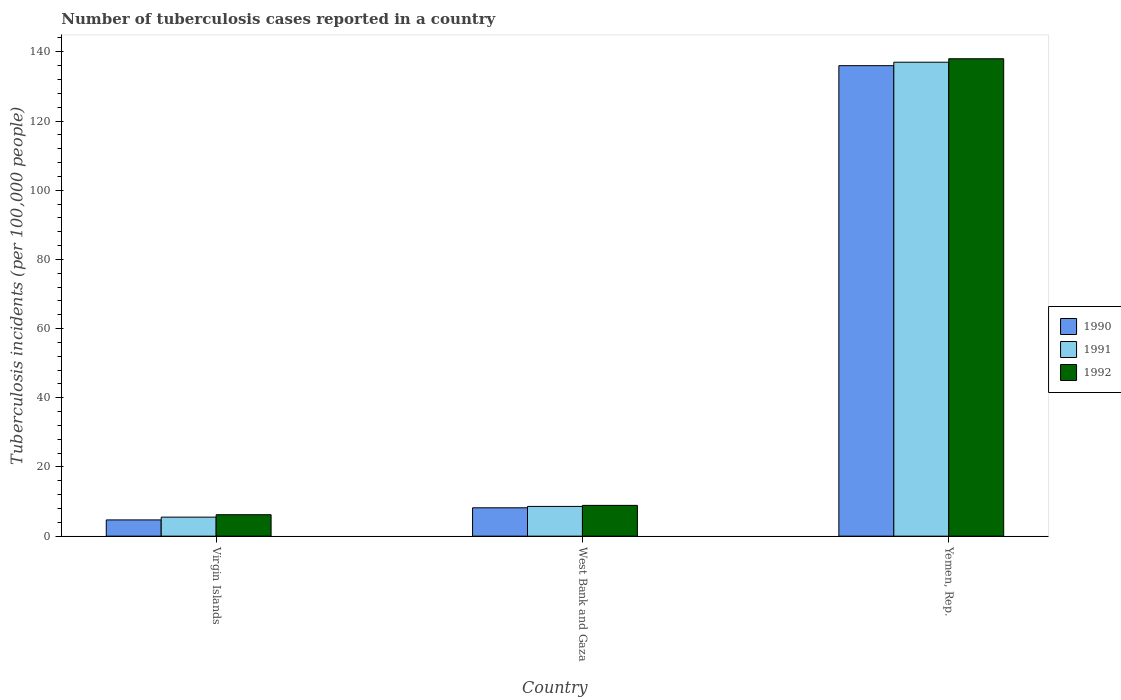How many groups of bars are there?
Keep it short and to the point. 3. Are the number of bars per tick equal to the number of legend labels?
Your response must be concise. Yes. How many bars are there on the 1st tick from the left?
Your answer should be compact. 3. What is the label of the 2nd group of bars from the left?
Ensure brevity in your answer.  West Bank and Gaza. In how many cases, is the number of bars for a given country not equal to the number of legend labels?
Your answer should be very brief. 0. Across all countries, what is the maximum number of tuberculosis cases reported in in 1992?
Ensure brevity in your answer.  138. Across all countries, what is the minimum number of tuberculosis cases reported in in 1992?
Offer a very short reply. 6.2. In which country was the number of tuberculosis cases reported in in 1990 maximum?
Offer a very short reply. Yemen, Rep. In which country was the number of tuberculosis cases reported in in 1991 minimum?
Ensure brevity in your answer.  Virgin Islands. What is the total number of tuberculosis cases reported in in 1990 in the graph?
Provide a short and direct response. 148.9. What is the difference between the number of tuberculosis cases reported in in 1991 in West Bank and Gaza and that in Yemen, Rep.?
Keep it short and to the point. -128.4. What is the difference between the number of tuberculosis cases reported in in 1992 in Virgin Islands and the number of tuberculosis cases reported in in 1990 in West Bank and Gaza?
Your answer should be compact. -2. What is the average number of tuberculosis cases reported in in 1990 per country?
Offer a terse response. 49.63. What is the difference between the number of tuberculosis cases reported in of/in 1992 and number of tuberculosis cases reported in of/in 1991 in Virgin Islands?
Offer a terse response. 0.7. What is the ratio of the number of tuberculosis cases reported in in 1991 in Virgin Islands to that in West Bank and Gaza?
Offer a very short reply. 0.64. What is the difference between the highest and the second highest number of tuberculosis cases reported in in 1991?
Your answer should be very brief. -128.4. What is the difference between the highest and the lowest number of tuberculosis cases reported in in 1991?
Give a very brief answer. 131.5. Is the sum of the number of tuberculosis cases reported in in 1990 in Virgin Islands and West Bank and Gaza greater than the maximum number of tuberculosis cases reported in in 1992 across all countries?
Make the answer very short. No. What does the 3rd bar from the right in Virgin Islands represents?
Provide a succinct answer. 1990. How many bars are there?
Ensure brevity in your answer.  9. What is the difference between two consecutive major ticks on the Y-axis?
Offer a terse response. 20. Are the values on the major ticks of Y-axis written in scientific E-notation?
Offer a terse response. No. Does the graph contain any zero values?
Keep it short and to the point. No. How are the legend labels stacked?
Provide a short and direct response. Vertical. What is the title of the graph?
Ensure brevity in your answer.  Number of tuberculosis cases reported in a country. What is the label or title of the X-axis?
Give a very brief answer. Country. What is the label or title of the Y-axis?
Your response must be concise. Tuberculosis incidents (per 100,0 people). What is the Tuberculosis incidents (per 100,000 people) in 1990 in Virgin Islands?
Keep it short and to the point. 4.7. What is the Tuberculosis incidents (per 100,000 people) of 1991 in Virgin Islands?
Offer a very short reply. 5.5. What is the Tuberculosis incidents (per 100,000 people) of 1991 in West Bank and Gaza?
Offer a terse response. 8.6. What is the Tuberculosis incidents (per 100,000 people) in 1992 in West Bank and Gaza?
Your answer should be very brief. 8.9. What is the Tuberculosis incidents (per 100,000 people) in 1990 in Yemen, Rep.?
Your answer should be very brief. 136. What is the Tuberculosis incidents (per 100,000 people) of 1991 in Yemen, Rep.?
Offer a very short reply. 137. What is the Tuberculosis incidents (per 100,000 people) in 1992 in Yemen, Rep.?
Your answer should be compact. 138. Across all countries, what is the maximum Tuberculosis incidents (per 100,000 people) in 1990?
Provide a short and direct response. 136. Across all countries, what is the maximum Tuberculosis incidents (per 100,000 people) of 1991?
Give a very brief answer. 137. Across all countries, what is the maximum Tuberculosis incidents (per 100,000 people) in 1992?
Make the answer very short. 138. Across all countries, what is the minimum Tuberculosis incidents (per 100,000 people) of 1992?
Offer a terse response. 6.2. What is the total Tuberculosis incidents (per 100,000 people) of 1990 in the graph?
Ensure brevity in your answer.  148.9. What is the total Tuberculosis incidents (per 100,000 people) in 1991 in the graph?
Keep it short and to the point. 151.1. What is the total Tuberculosis incidents (per 100,000 people) in 1992 in the graph?
Your answer should be very brief. 153.1. What is the difference between the Tuberculosis incidents (per 100,000 people) of 1991 in Virgin Islands and that in West Bank and Gaza?
Your answer should be compact. -3.1. What is the difference between the Tuberculosis incidents (per 100,000 people) of 1990 in Virgin Islands and that in Yemen, Rep.?
Offer a terse response. -131.3. What is the difference between the Tuberculosis incidents (per 100,000 people) in 1991 in Virgin Islands and that in Yemen, Rep.?
Offer a very short reply. -131.5. What is the difference between the Tuberculosis incidents (per 100,000 people) in 1992 in Virgin Islands and that in Yemen, Rep.?
Provide a short and direct response. -131.8. What is the difference between the Tuberculosis incidents (per 100,000 people) in 1990 in West Bank and Gaza and that in Yemen, Rep.?
Make the answer very short. -127.8. What is the difference between the Tuberculosis incidents (per 100,000 people) in 1991 in West Bank and Gaza and that in Yemen, Rep.?
Provide a succinct answer. -128.4. What is the difference between the Tuberculosis incidents (per 100,000 people) of 1992 in West Bank and Gaza and that in Yemen, Rep.?
Make the answer very short. -129.1. What is the difference between the Tuberculosis incidents (per 100,000 people) in 1990 in Virgin Islands and the Tuberculosis incidents (per 100,000 people) in 1991 in West Bank and Gaza?
Provide a succinct answer. -3.9. What is the difference between the Tuberculosis incidents (per 100,000 people) in 1991 in Virgin Islands and the Tuberculosis incidents (per 100,000 people) in 1992 in West Bank and Gaza?
Offer a very short reply. -3.4. What is the difference between the Tuberculosis incidents (per 100,000 people) in 1990 in Virgin Islands and the Tuberculosis incidents (per 100,000 people) in 1991 in Yemen, Rep.?
Your answer should be compact. -132.3. What is the difference between the Tuberculosis incidents (per 100,000 people) of 1990 in Virgin Islands and the Tuberculosis incidents (per 100,000 people) of 1992 in Yemen, Rep.?
Keep it short and to the point. -133.3. What is the difference between the Tuberculosis incidents (per 100,000 people) in 1991 in Virgin Islands and the Tuberculosis incidents (per 100,000 people) in 1992 in Yemen, Rep.?
Your response must be concise. -132.5. What is the difference between the Tuberculosis incidents (per 100,000 people) in 1990 in West Bank and Gaza and the Tuberculosis incidents (per 100,000 people) in 1991 in Yemen, Rep.?
Your answer should be compact. -128.8. What is the difference between the Tuberculosis incidents (per 100,000 people) in 1990 in West Bank and Gaza and the Tuberculosis incidents (per 100,000 people) in 1992 in Yemen, Rep.?
Your answer should be very brief. -129.8. What is the difference between the Tuberculosis incidents (per 100,000 people) of 1991 in West Bank and Gaza and the Tuberculosis incidents (per 100,000 people) of 1992 in Yemen, Rep.?
Offer a very short reply. -129.4. What is the average Tuberculosis incidents (per 100,000 people) of 1990 per country?
Your answer should be compact. 49.63. What is the average Tuberculosis incidents (per 100,000 people) of 1991 per country?
Make the answer very short. 50.37. What is the average Tuberculosis incidents (per 100,000 people) of 1992 per country?
Ensure brevity in your answer.  51.03. What is the difference between the Tuberculosis incidents (per 100,000 people) of 1990 and Tuberculosis incidents (per 100,000 people) of 1992 in Virgin Islands?
Your response must be concise. -1.5. What is the difference between the Tuberculosis incidents (per 100,000 people) in 1990 and Tuberculosis incidents (per 100,000 people) in 1991 in Yemen, Rep.?
Offer a very short reply. -1. What is the ratio of the Tuberculosis incidents (per 100,000 people) in 1990 in Virgin Islands to that in West Bank and Gaza?
Your response must be concise. 0.57. What is the ratio of the Tuberculosis incidents (per 100,000 people) in 1991 in Virgin Islands to that in West Bank and Gaza?
Give a very brief answer. 0.64. What is the ratio of the Tuberculosis incidents (per 100,000 people) of 1992 in Virgin Islands to that in West Bank and Gaza?
Ensure brevity in your answer.  0.7. What is the ratio of the Tuberculosis incidents (per 100,000 people) of 1990 in Virgin Islands to that in Yemen, Rep.?
Your answer should be very brief. 0.03. What is the ratio of the Tuberculosis incidents (per 100,000 people) of 1991 in Virgin Islands to that in Yemen, Rep.?
Your answer should be compact. 0.04. What is the ratio of the Tuberculosis incidents (per 100,000 people) in 1992 in Virgin Islands to that in Yemen, Rep.?
Ensure brevity in your answer.  0.04. What is the ratio of the Tuberculosis incidents (per 100,000 people) in 1990 in West Bank and Gaza to that in Yemen, Rep.?
Offer a very short reply. 0.06. What is the ratio of the Tuberculosis incidents (per 100,000 people) in 1991 in West Bank and Gaza to that in Yemen, Rep.?
Provide a short and direct response. 0.06. What is the ratio of the Tuberculosis incidents (per 100,000 people) of 1992 in West Bank and Gaza to that in Yemen, Rep.?
Keep it short and to the point. 0.06. What is the difference between the highest and the second highest Tuberculosis incidents (per 100,000 people) of 1990?
Offer a very short reply. 127.8. What is the difference between the highest and the second highest Tuberculosis incidents (per 100,000 people) of 1991?
Ensure brevity in your answer.  128.4. What is the difference between the highest and the second highest Tuberculosis incidents (per 100,000 people) of 1992?
Your answer should be compact. 129.1. What is the difference between the highest and the lowest Tuberculosis incidents (per 100,000 people) of 1990?
Offer a terse response. 131.3. What is the difference between the highest and the lowest Tuberculosis incidents (per 100,000 people) in 1991?
Your answer should be compact. 131.5. What is the difference between the highest and the lowest Tuberculosis incidents (per 100,000 people) of 1992?
Offer a terse response. 131.8. 